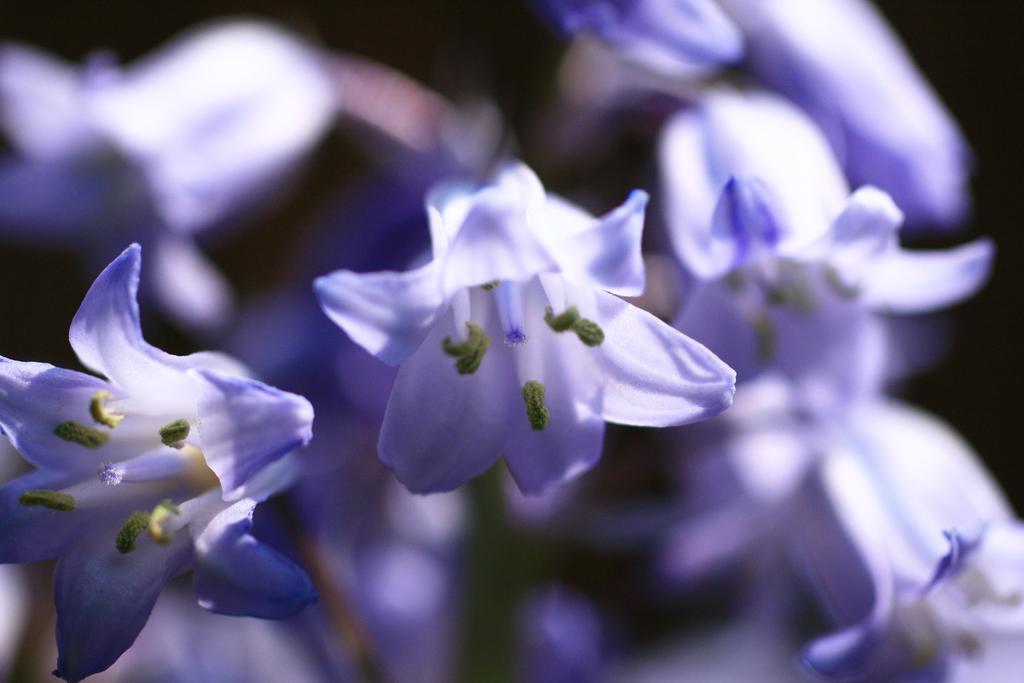How would you summarize this image in a sentence or two? In this image in the foreground there are some flowers, and in the background also some flowers and there is a blurred background. 